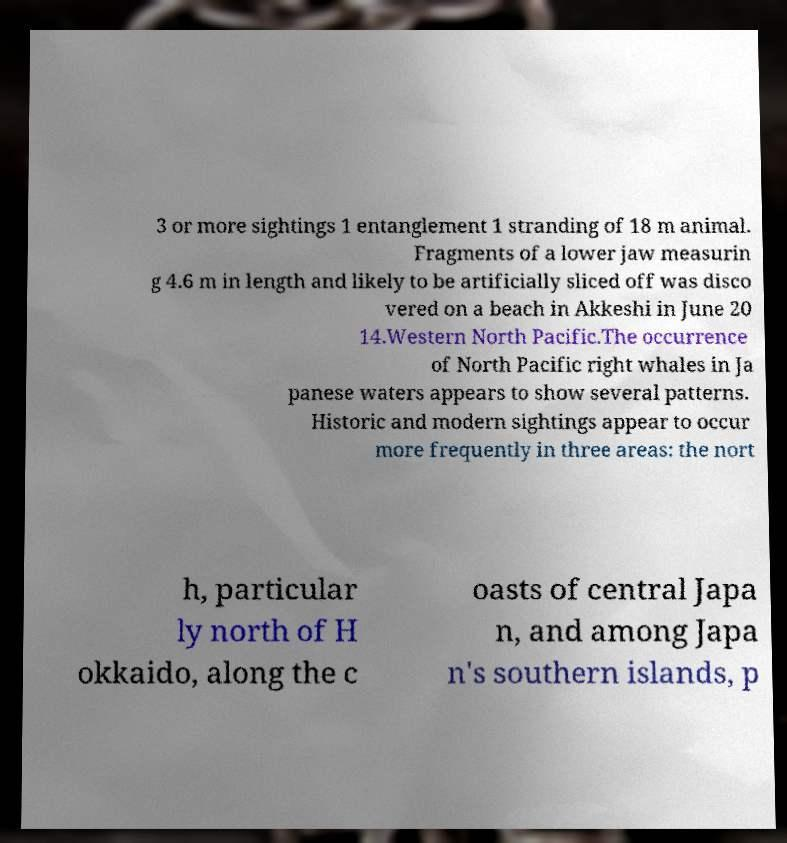I need the written content from this picture converted into text. Can you do that? 3 or more sightings 1 entanglement 1 stranding of 18 m animal. Fragments of a lower jaw measurin g 4.6 m in length and likely to be artificially sliced off was disco vered on a beach in Akkeshi in June 20 14.Western North Pacific.The occurrence of North Pacific right whales in Ja panese waters appears to show several patterns. Historic and modern sightings appear to occur more frequently in three areas: the nort h, particular ly north of H okkaido, along the c oasts of central Japa n, and among Japa n's southern islands, p 